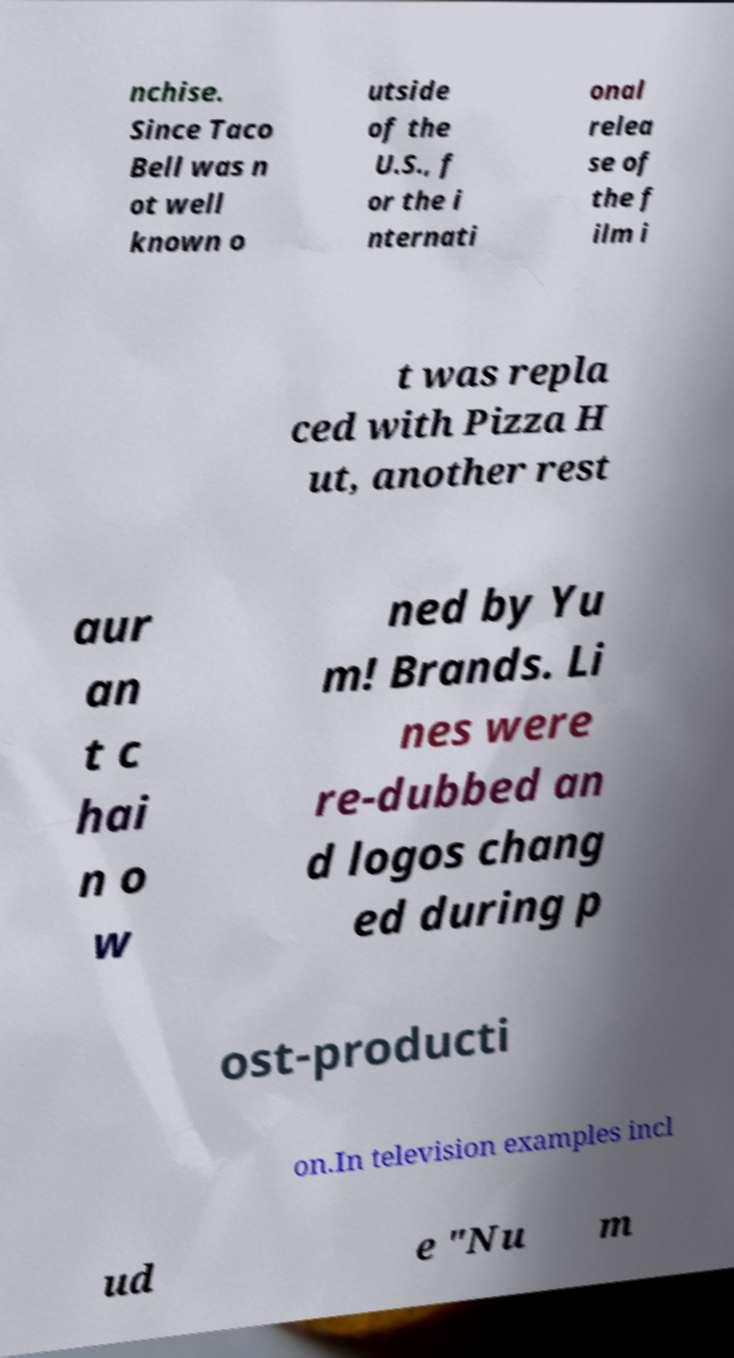Could you extract and type out the text from this image? nchise. Since Taco Bell was n ot well known o utside of the U.S., f or the i nternati onal relea se of the f ilm i t was repla ced with Pizza H ut, another rest aur an t c hai n o w ned by Yu m! Brands. Li nes were re-dubbed an d logos chang ed during p ost-producti on.In television examples incl ud e "Nu m 